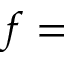Convert formula to latex. <formula><loc_0><loc_0><loc_500><loc_500>f =</formula> 